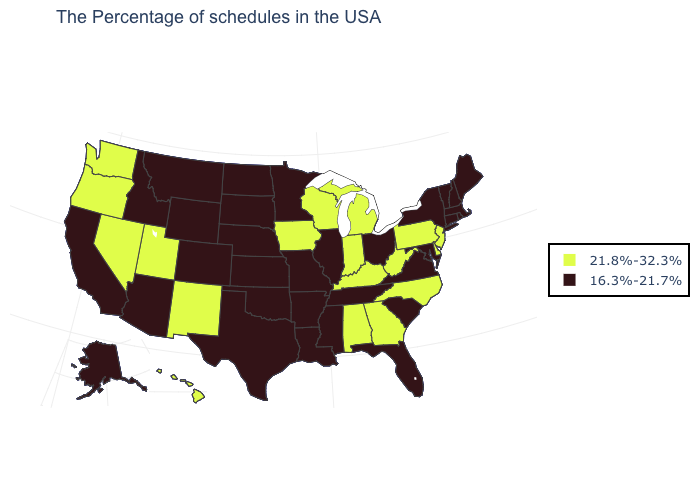What is the value of South Carolina?
Quick response, please. 16.3%-21.7%. What is the value of Texas?
Write a very short answer. 16.3%-21.7%. What is the value of Oklahoma?
Write a very short answer. 16.3%-21.7%. Name the states that have a value in the range 21.8%-32.3%?
Write a very short answer. New Jersey, Delaware, Pennsylvania, North Carolina, West Virginia, Georgia, Michigan, Kentucky, Indiana, Alabama, Wisconsin, Iowa, New Mexico, Utah, Nevada, Washington, Oregon, Hawaii. Among the states that border Tennessee , which have the highest value?
Give a very brief answer. North Carolina, Georgia, Kentucky, Alabama. Does Washington have the highest value in the USA?
Quick response, please. Yes. Which states have the lowest value in the USA?
Give a very brief answer. Maine, Massachusetts, Rhode Island, New Hampshire, Vermont, Connecticut, New York, Maryland, Virginia, South Carolina, Ohio, Florida, Tennessee, Illinois, Mississippi, Louisiana, Missouri, Arkansas, Minnesota, Kansas, Nebraska, Oklahoma, Texas, South Dakota, North Dakota, Wyoming, Colorado, Montana, Arizona, Idaho, California, Alaska. How many symbols are there in the legend?
Short answer required. 2. Which states have the lowest value in the MidWest?
Give a very brief answer. Ohio, Illinois, Missouri, Minnesota, Kansas, Nebraska, South Dakota, North Dakota. What is the lowest value in the USA?
Give a very brief answer. 16.3%-21.7%. Which states have the lowest value in the MidWest?
Keep it brief. Ohio, Illinois, Missouri, Minnesota, Kansas, Nebraska, South Dakota, North Dakota. Name the states that have a value in the range 21.8%-32.3%?
Keep it brief. New Jersey, Delaware, Pennsylvania, North Carolina, West Virginia, Georgia, Michigan, Kentucky, Indiana, Alabama, Wisconsin, Iowa, New Mexico, Utah, Nevada, Washington, Oregon, Hawaii. What is the value of Wisconsin?
Concise answer only. 21.8%-32.3%. Does Colorado have the lowest value in the West?
Keep it brief. Yes. 